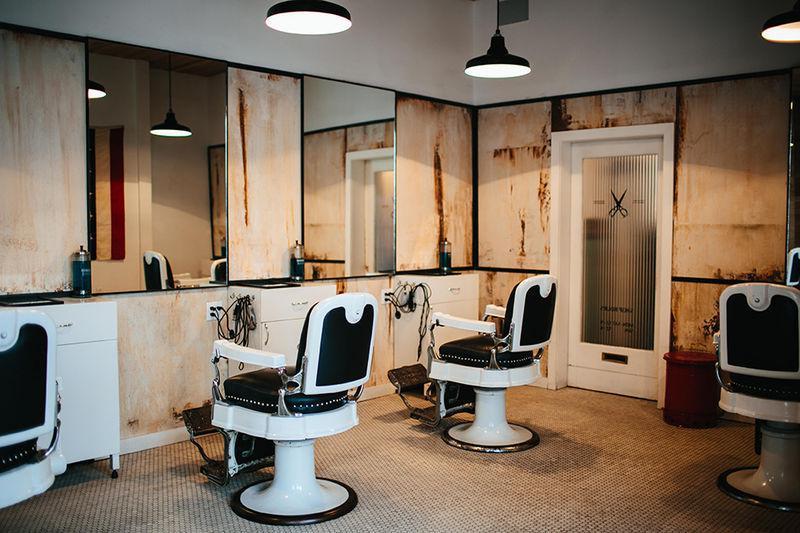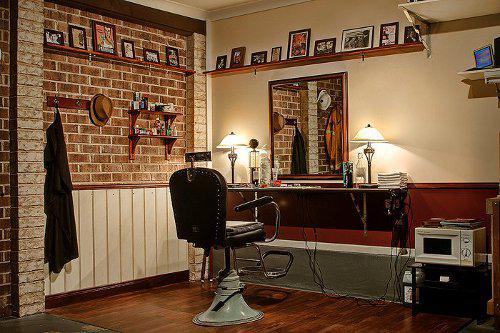The first image is the image on the left, the second image is the image on the right. Assess this claim about the two images: "An exposed brick wall is shown in exactly one image.". Correct or not? Answer yes or no. Yes. 